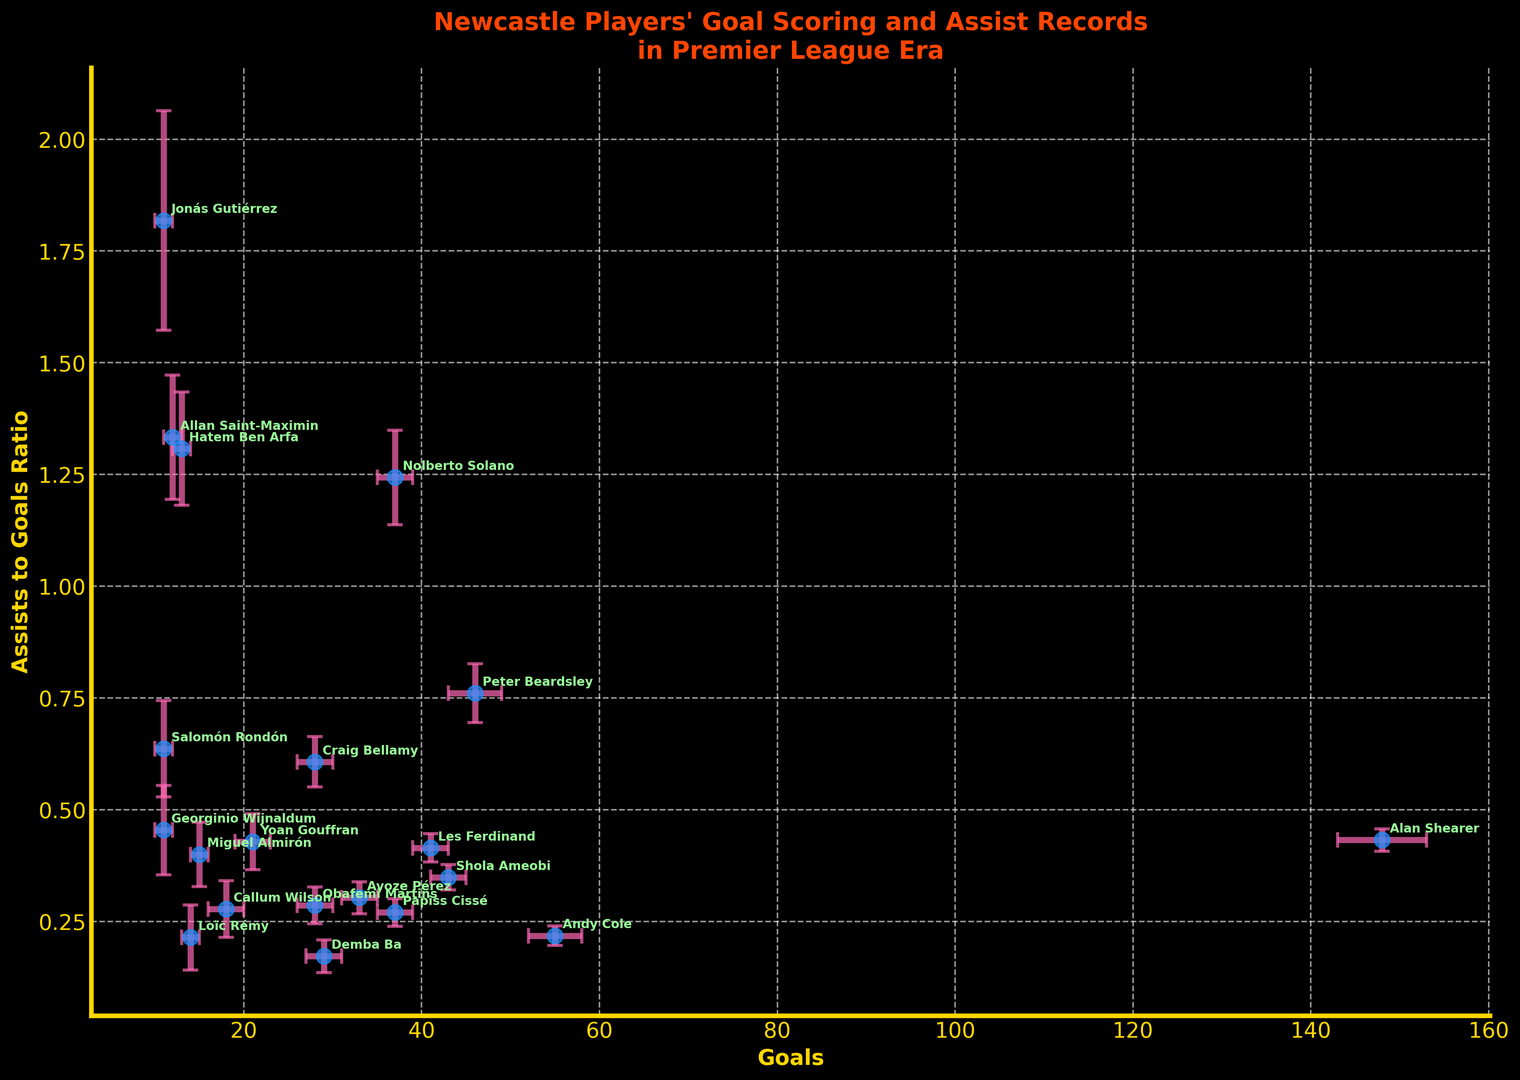Who has the highest assist-to-goal ratio? Look at the y-axis values and identify the highest point on the plot. The player with the highest position on the y-axis has the highest ratio.
Answer: Nolberto Solano How does Alan Shearer's assist-to-goal ratio compare to that of Shola Ameobi? Compare the y-axis value (assist-to-goal ratio) for Alan Shearer and Shola Ameobi. Alan Shearer's ratio is lower than Shola Ameobi's ratio.
Answer: Alan Shearer's ratio is lower Which player has more goals but a lower assist-to-goal ratio than Peter Beardsley? Peter Beardsley has a certain number of goals and an assist-to-goal ratio visible on the plot. Compare other players to find one with more goals positioned to the left of Peter but a lower ratio below Peter.
Answer: Andy Cole What is the general trend between goals scored and assist-to-goal ratio? Observe the plot's scatter pattern, determining whether higher goals tend to associate with higher or lower assist-to-goal ratios.
Answer: Mixed trend but generally lower ratio with higher goals Who has the highest error margin in assists? Identify the player with the largest error bars on the y-axis, which indicate the highest error margin in assists.
Answer: Nolberto Solano Which player has the lowest assist-to-goal ratio among those with at least 30 goals? Filter players with at least 30 goals using the x-axis, then find the one with the lowest position on the y-axis.
Answer: Andy Cole Is there any visible correlation between the number of goals and the assists-to-goal ratio? Observe whether more goals visibly trend upwards or downwards in the plot, indicating any correlation direction.
Answer: No clear correlation Who has an assist-to-goal ratio roughly close to 0.5? Look for players whose points align closely with the 0.5 mark on the y-axis.
Answer: Peter Beardsley What can you infer about Craig Bellamy’s goal-scoring and playmaking abilities? Locate Craig Bellamy’s point on both axes. He has relatively few goals but a high assist-to-goal ratio, implying he may be better at playmaking than scoring.
Answer: Better playmaker How many players have an assist-to-goal ratio higher than 0.6? Count the number of points above the 0.6 mark on the y-axis.
Answer: 3 